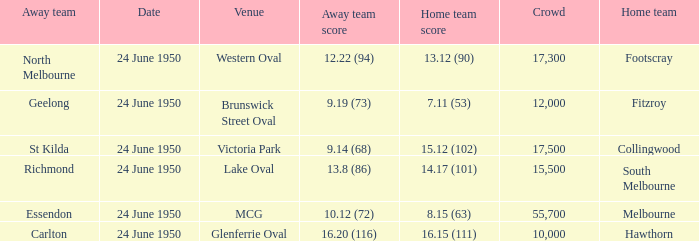Who was the home team for the game where North Melbourne was the away team? Footscray. Help me parse the entirety of this table. {'header': ['Away team', 'Date', 'Venue', 'Away team score', 'Home team score', 'Crowd', 'Home team'], 'rows': [['North Melbourne', '24 June 1950', 'Western Oval', '12.22 (94)', '13.12 (90)', '17,300', 'Footscray'], ['Geelong', '24 June 1950', 'Brunswick Street Oval', '9.19 (73)', '7.11 (53)', '12,000', 'Fitzroy'], ['St Kilda', '24 June 1950', 'Victoria Park', '9.14 (68)', '15.12 (102)', '17,500', 'Collingwood'], ['Richmond', '24 June 1950', 'Lake Oval', '13.8 (86)', '14.17 (101)', '15,500', 'South Melbourne'], ['Essendon', '24 June 1950', 'MCG', '10.12 (72)', '8.15 (63)', '55,700', 'Melbourne'], ['Carlton', '24 June 1950', 'Glenferrie Oval', '16.20 (116)', '16.15 (111)', '10,000', 'Hawthorn']]} 